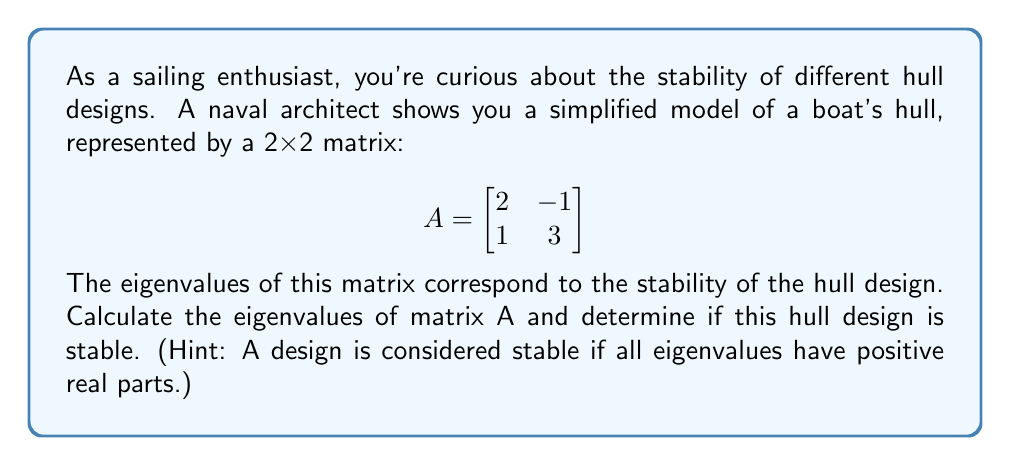Give your solution to this math problem. To find the eigenvalues of matrix A, we need to solve the characteristic equation:

1. Set up the characteristic equation:
   $$det(A - \lambda I) = 0$$
   where $I$ is the 2x2 identity matrix and $\lambda$ represents the eigenvalues.

2. Expand the determinant:
   $$det\begin{bmatrix} 
   2-\lambda & -1 \\
   1 & 3-\lambda
   \end{bmatrix} = 0$$

3. Calculate the determinant:
   $$(2-\lambda)(3-\lambda) - (-1)(1) = 0$$
   $$6 - 5\lambda + \lambda^2 + 1 = 0$$
   $$\lambda^2 - 5\lambda + 7 = 0$$

4. Solve the quadratic equation using the quadratic formula:
   $$\lambda = \frac{-b \pm \sqrt{b^2 - 4ac}}{2a}$$
   where $a=1$, $b=-5$, and $c=7$

5. Calculate the eigenvalues:
   $$\lambda = \frac{5 \pm \sqrt{25 - 28}}{2} = \frac{5 \pm \sqrt{-3}}{2}$$

6. Simplify the results:
   $$\lambda_1 = \frac{5 + i\sqrt{3}}{2} \approx 2.5 + 0.866i$$
   $$\lambda_2 = \frac{5 - i\sqrt{3}}{2} \approx 2.5 - 0.866i$$

7. Analyze stability:
   Both eigenvalues have a positive real part (2.5), which means the hull design is stable.
Answer: The eigenvalues are $\lambda_1 = \frac{5 + i\sqrt{3}}{2}$ and $\lambda_2 = \frac{5 - i\sqrt{3}}{2}$. Since both eigenvalues have positive real parts, the hull design is stable. 